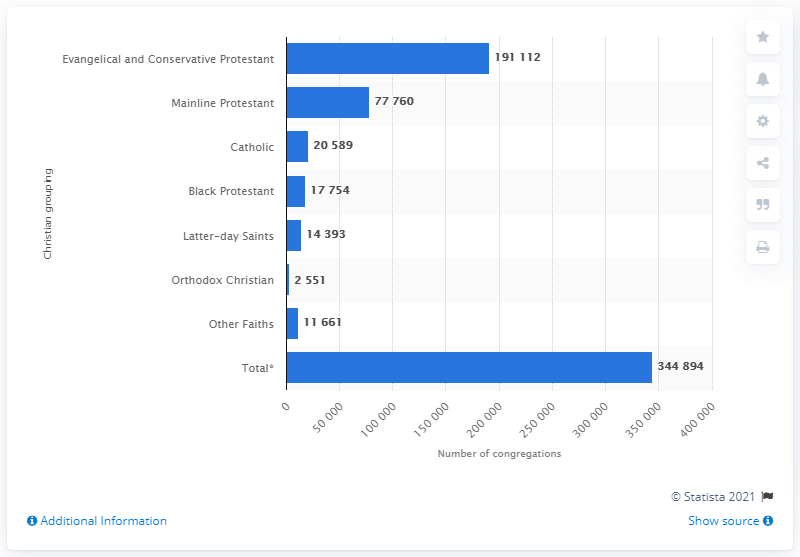Indicate a few pertinent items in this graphic. The Latter-day Saints were the largest Christian denomination in the United States in 2010. 